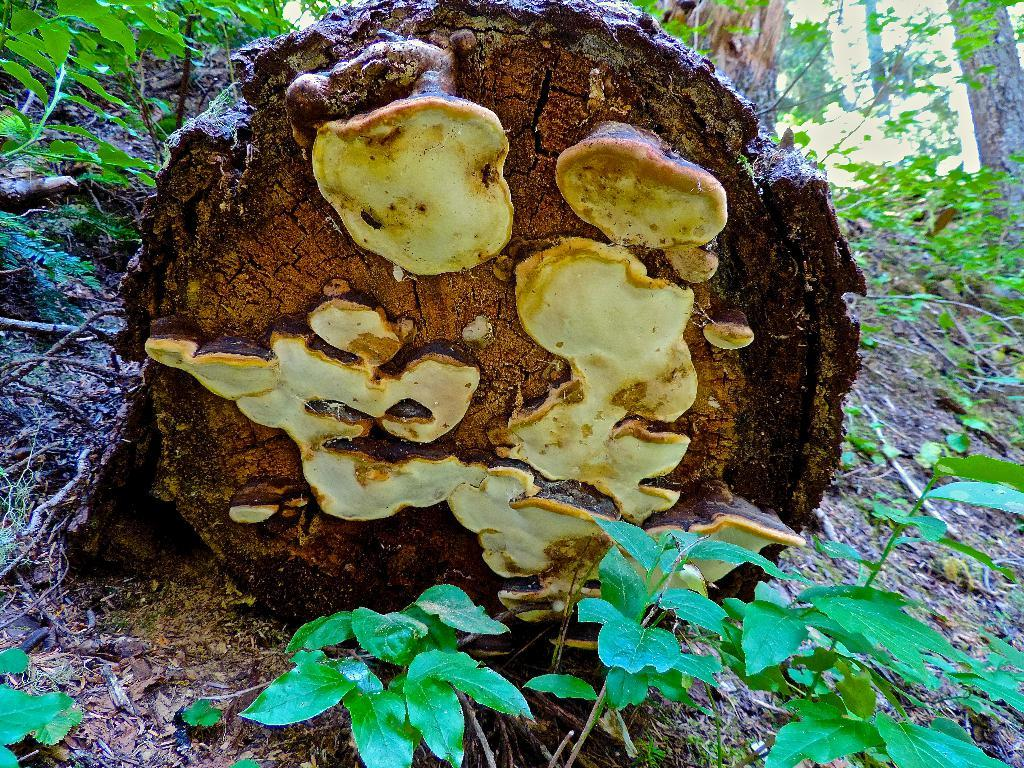What is the main subject of the image? The main subject of the image is the bark of a tree. What else can be seen at the bottom of the image? There are small plants at the bottom of the image. Can you describe the setting of the image? The image appears to be taken in a forest. What type of hose is being used by the father in the image? There is no hose or father present in the image; it features the bark of a tree and small plants in a forest setting. 